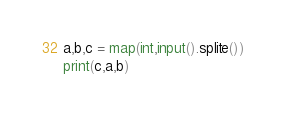<code> <loc_0><loc_0><loc_500><loc_500><_Python_>a,b,c = map(int,input().splite())
print(c,a,b)
</code> 